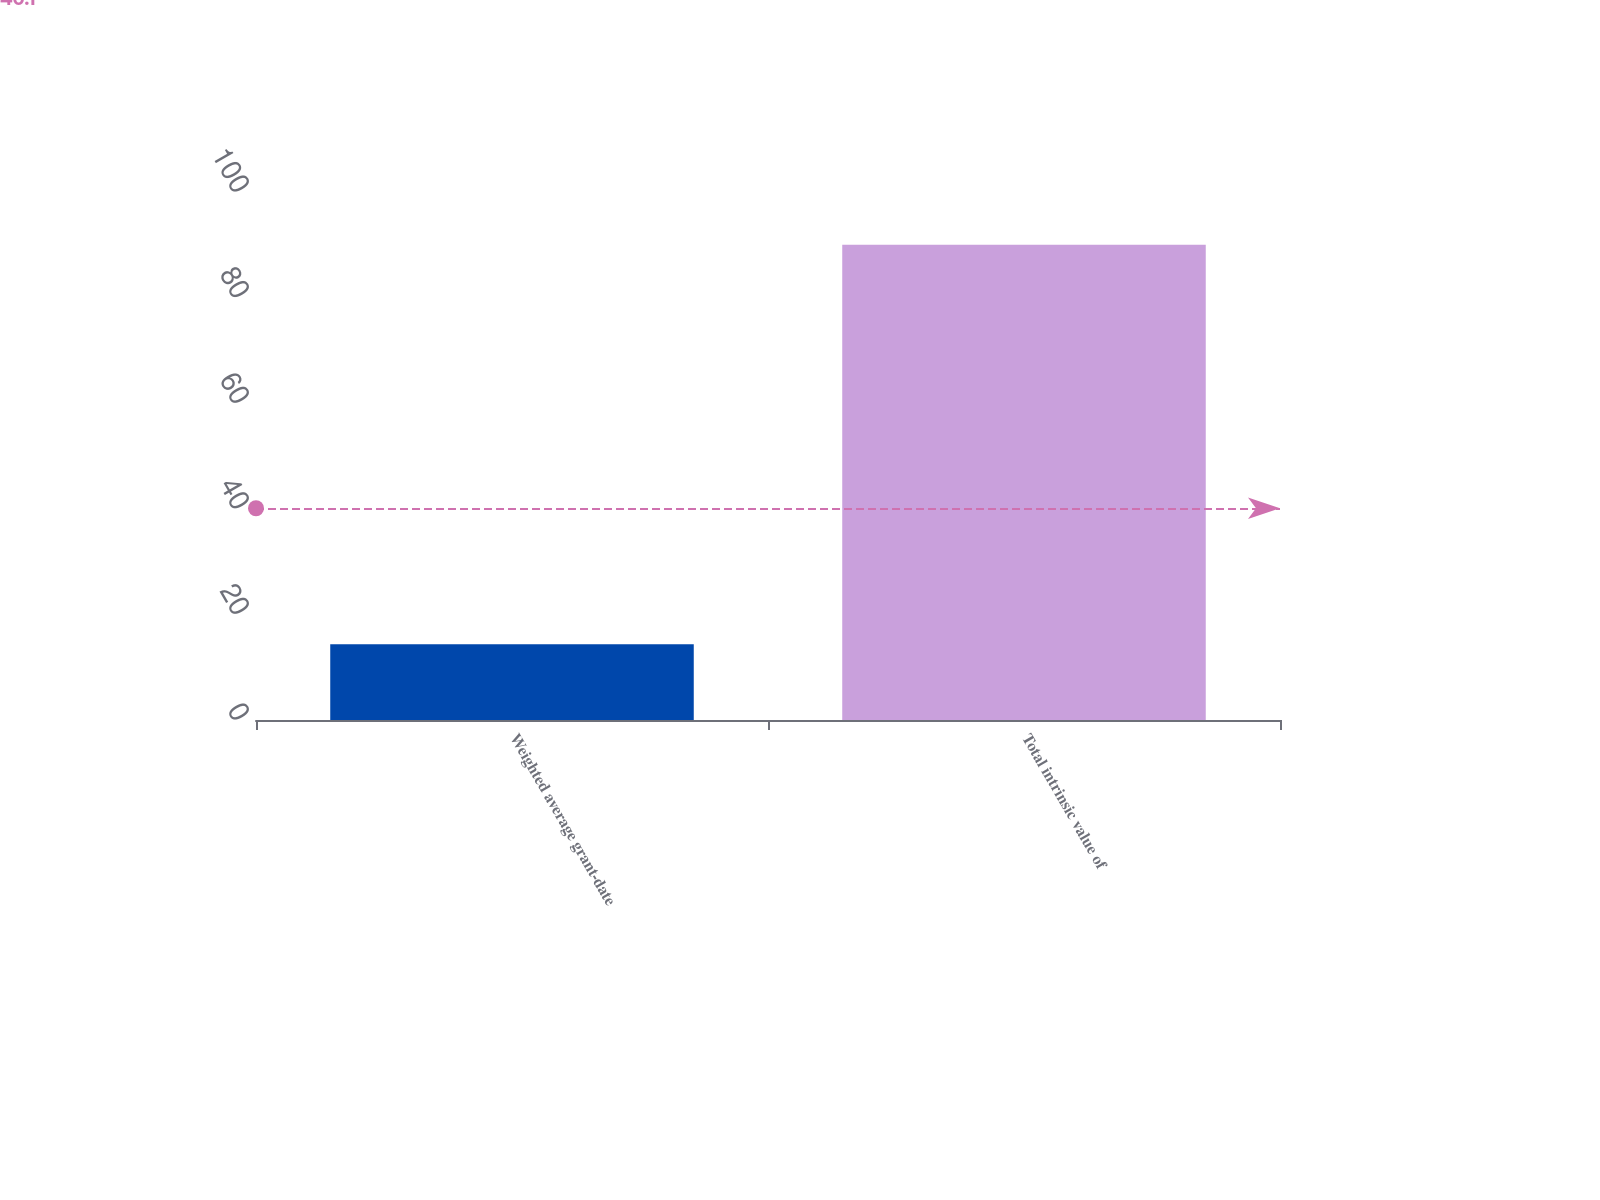Convert chart. <chart><loc_0><loc_0><loc_500><loc_500><bar_chart><fcel>Weighted average grant-date<fcel>Total intrinsic value of<nl><fcel>14.36<fcel>90<nl></chart> 